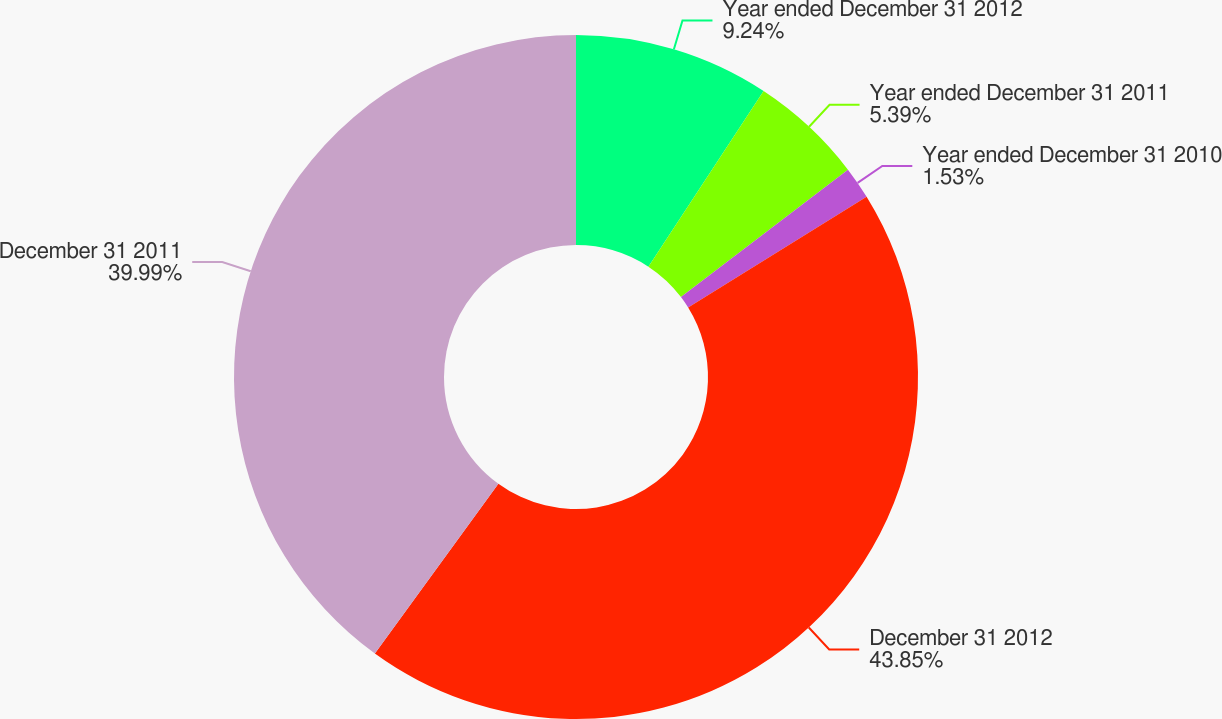Convert chart to OTSL. <chart><loc_0><loc_0><loc_500><loc_500><pie_chart><fcel>Year ended December 31 2012<fcel>Year ended December 31 2011<fcel>Year ended December 31 2010<fcel>December 31 2012<fcel>December 31 2011<nl><fcel>9.24%<fcel>5.39%<fcel>1.53%<fcel>43.84%<fcel>39.99%<nl></chart> 